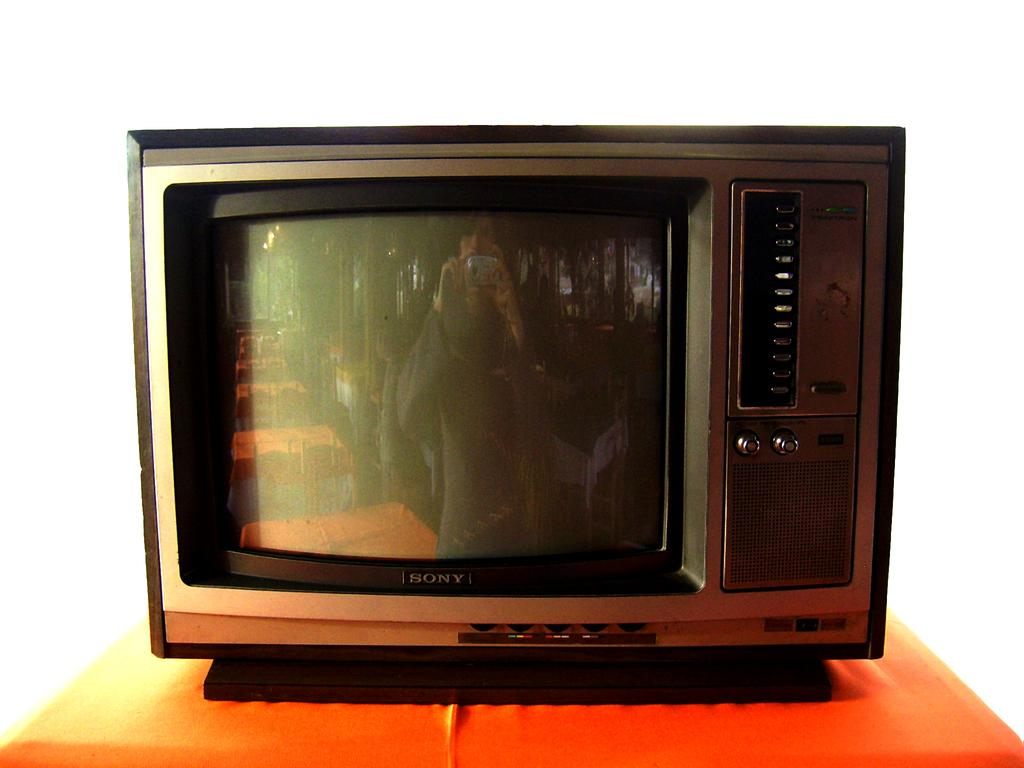<image>
Give a short and clear explanation of the subsequent image. An old fashioned Sony TV on an orange table. 